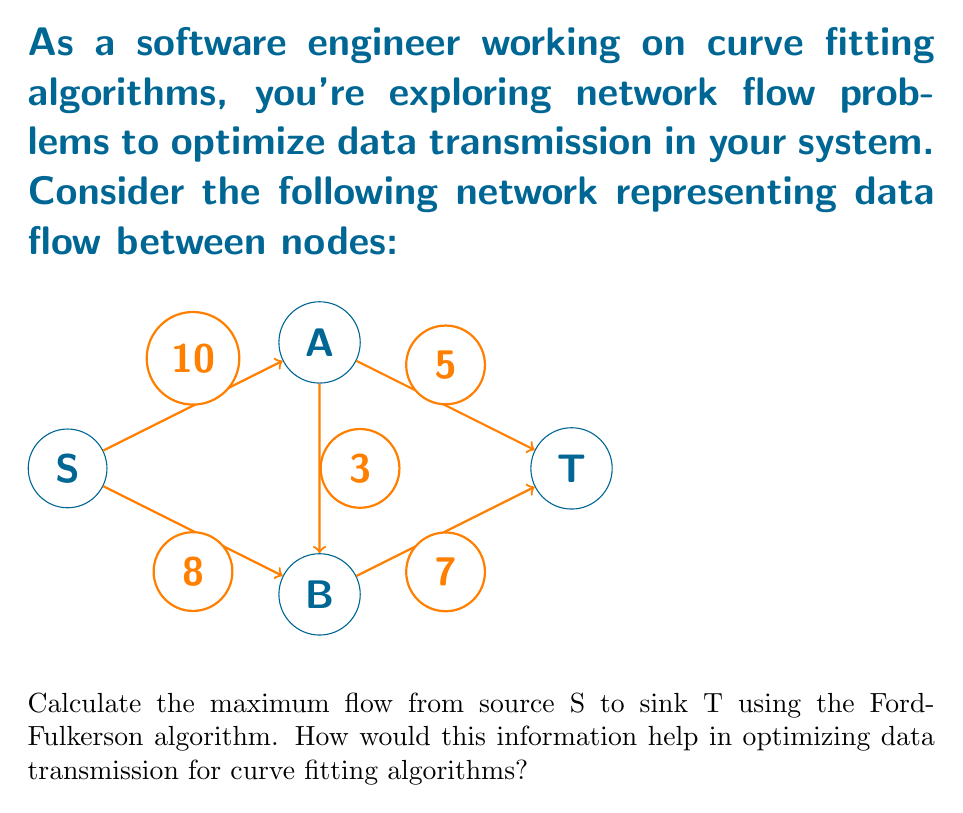Teach me how to tackle this problem. Let's apply the Ford-Fulkerson algorithm to find the maximum flow:

1) Initialize flow to 0 for all edges.

2) Find an augmenting path from S to T:
   Path 1: S -> A -> T (min capacity = 5)
   Increase flow by 5: 
   $$f(S,A) = 5, f(A,T) = 5$$

3) Find another augmenting path:
   Path 2: S -> B -> T (min capacity = 7)
   Increase flow by 7:
   $$f(S,B) = 7, f(B,T) = 7$$

4) Find another augmenting path:
   Path 3: S -> A -> B -> T (min capacity = 3)
   Increase flow by 3:
   $$f(S,A) = 8, f(A,B) = 3, f(B,T) = 7 + 3 = 10$$

5) No more augmenting paths exist. The maximum flow is the sum of all flows out of S:
   $$\text{Max Flow} = f(S,A) + f(S,B) = 8 + 7 = 15$$

This result helps optimize data transmission for curve fitting algorithms by:
1) Identifying the maximum data throughput between nodes.
2) Highlighting potential bottlenecks (e.g., the A->T edge).
3) Guiding the distribution of computational load across the network.
4) Informing decisions on where to place data caches or processing units to maximize efficiency.

Understanding the maximum flow allows for better resource allocation and can lead to more efficient parallel processing of curve fitting tasks across distributed systems.
Answer: 15 units 